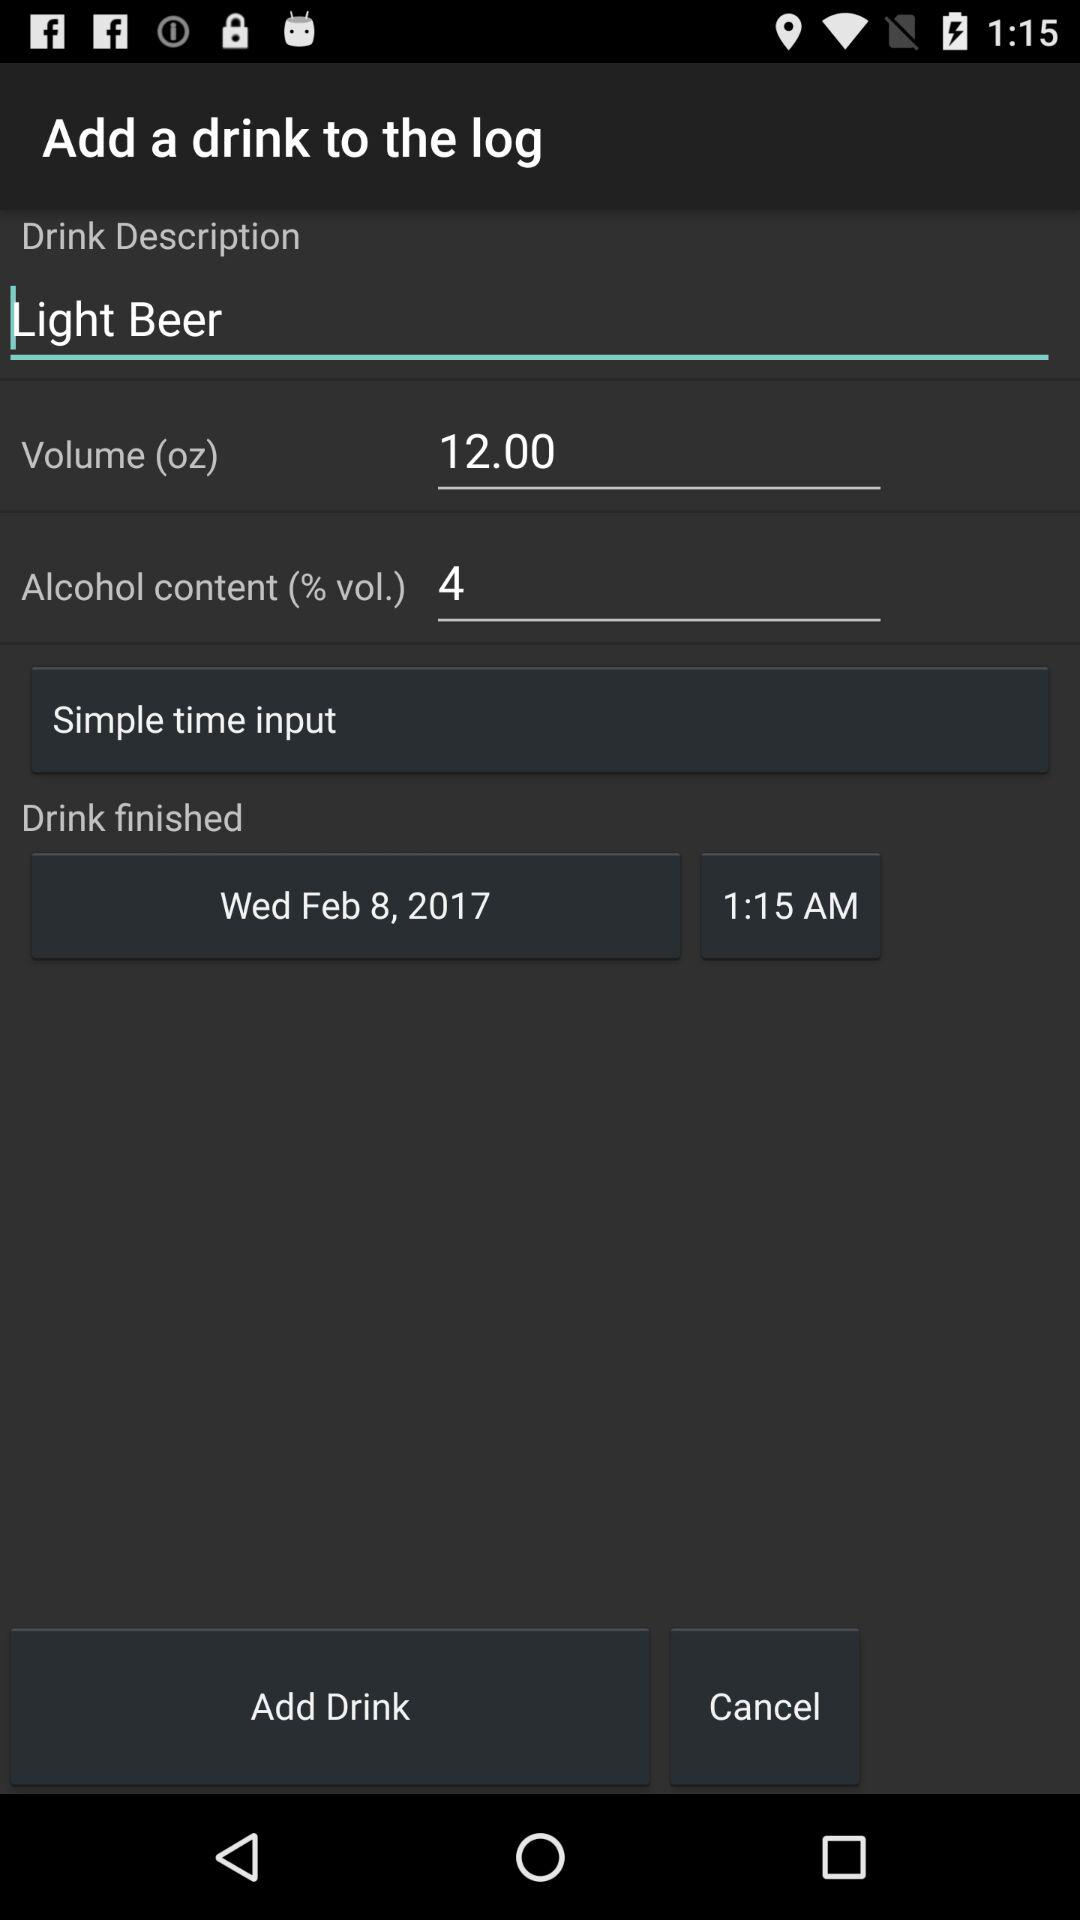What is the volume in ounces? The volume is 12 ounces. 